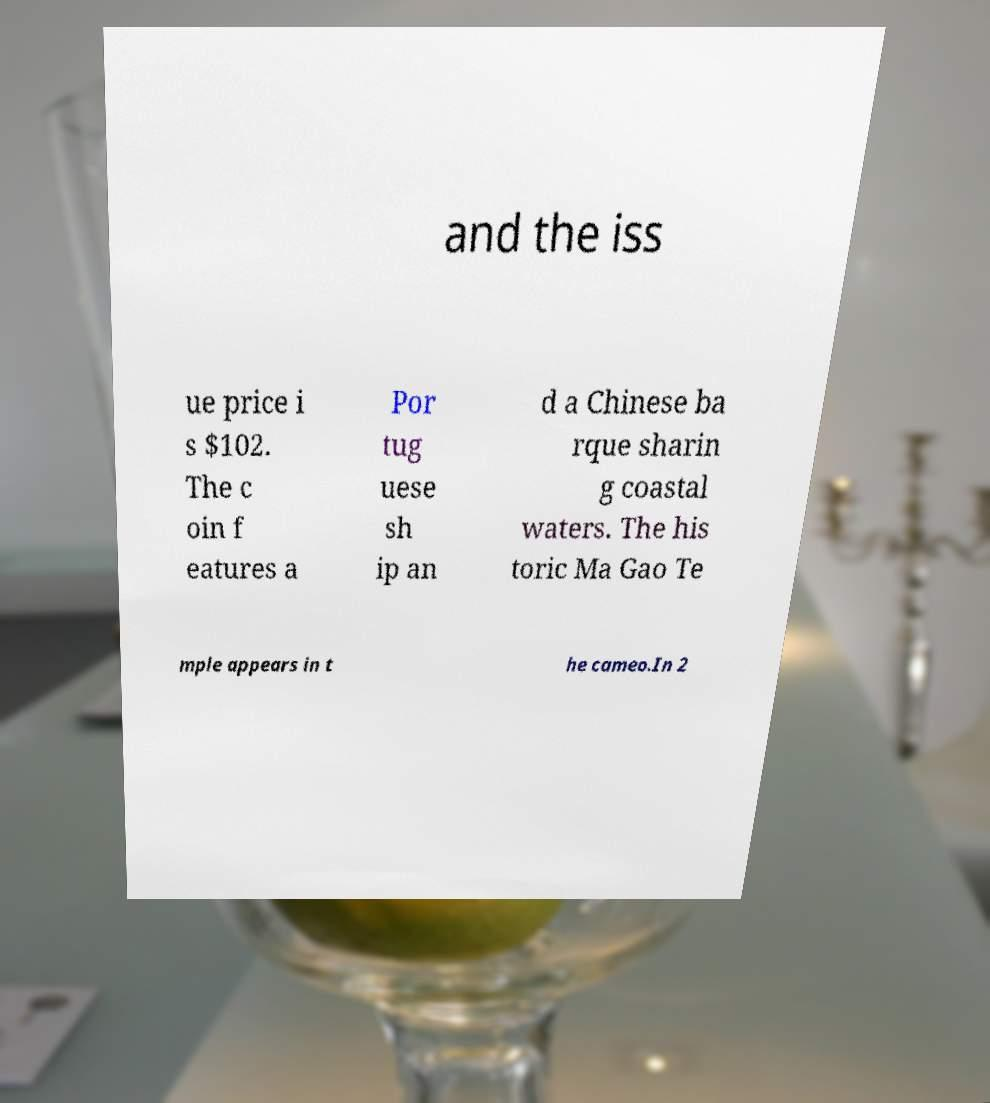For documentation purposes, I need the text within this image transcribed. Could you provide that? and the iss ue price i s $102. The c oin f eatures a Por tug uese sh ip an d a Chinese ba rque sharin g coastal waters. The his toric Ma Gao Te mple appears in t he cameo.In 2 